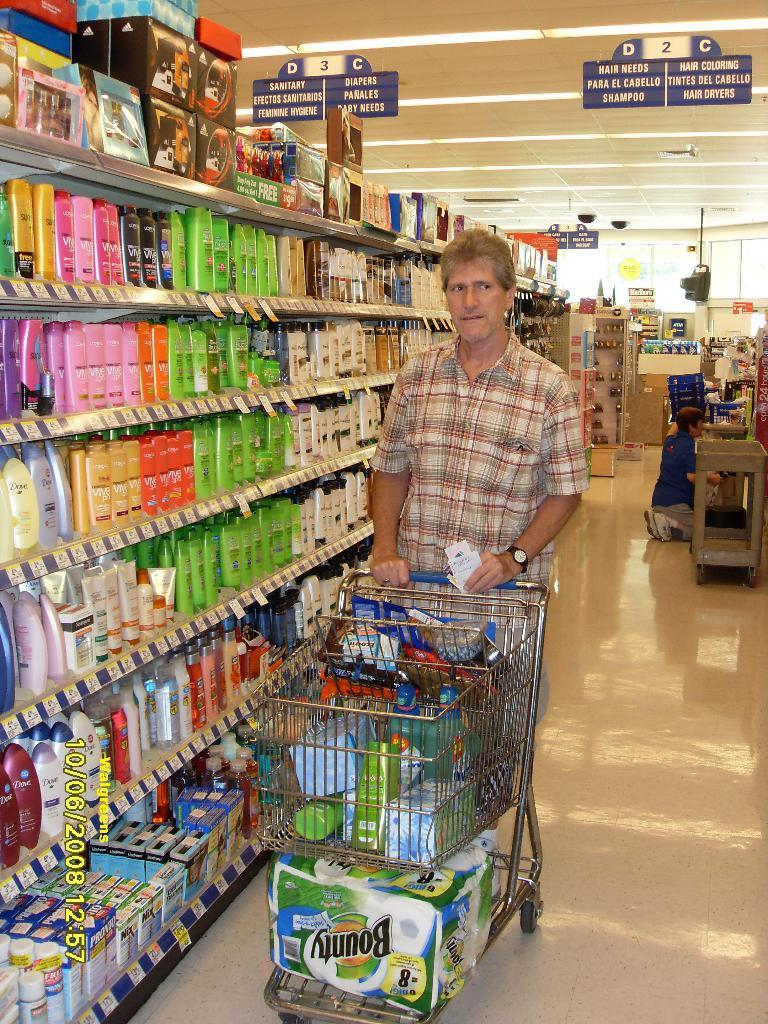<image>
Describe the image concisely. A man is walking with a cart full of stuff in the hair needs alley. 